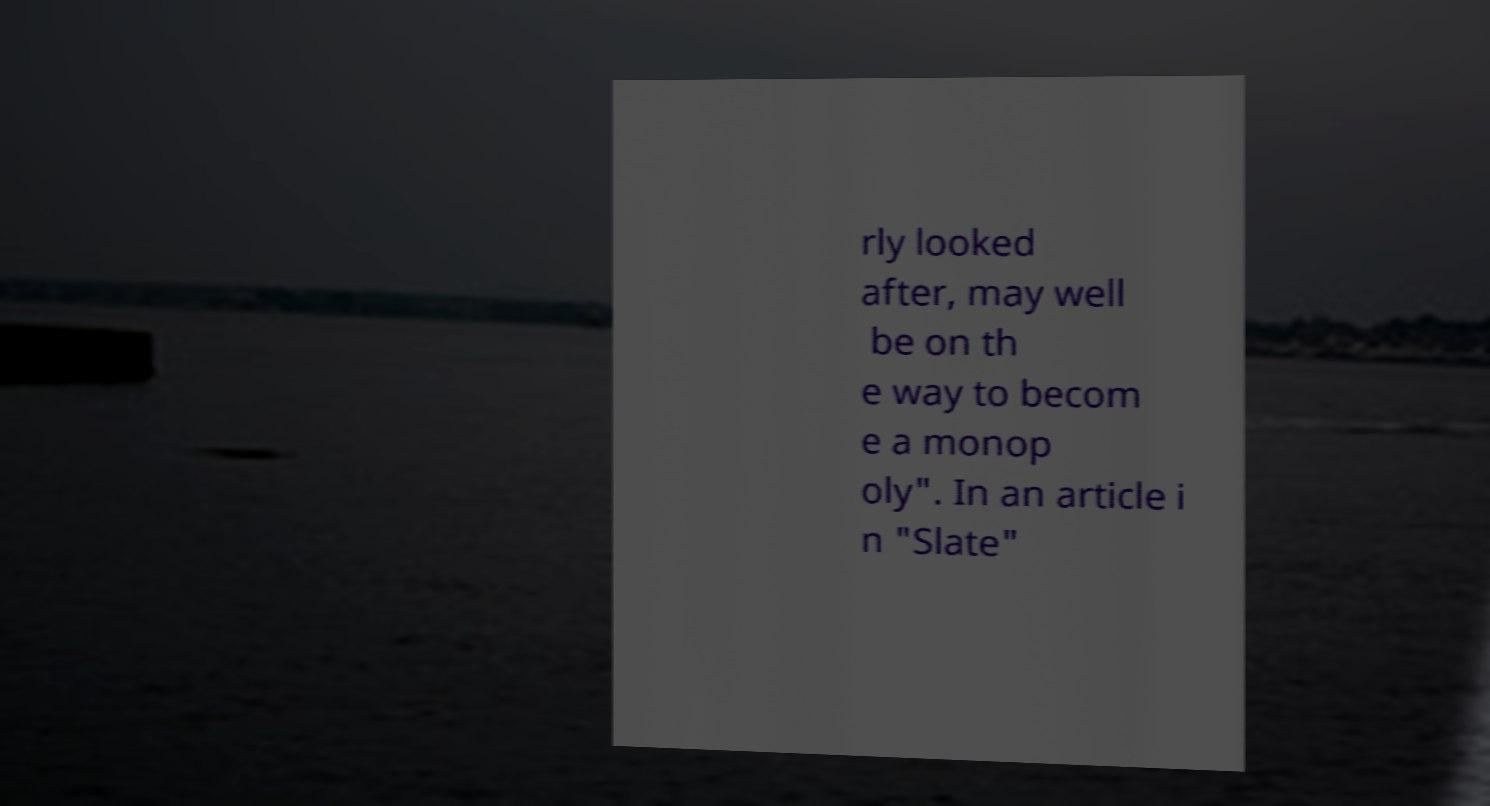Could you assist in decoding the text presented in this image and type it out clearly? rly looked after, may well be on th e way to becom e a monop oly". In an article i n "Slate" 